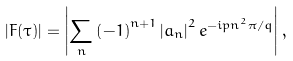Convert formula to latex. <formula><loc_0><loc_0><loc_500><loc_500>\left | F ( \tau ) \right | = \left | \sum _ { n } \left ( - 1 \right ) ^ { n + 1 } \left | a _ { n } \right | ^ { 2 } e ^ { - i p n ^ { 2 } \pi / q } \right | ,</formula> 